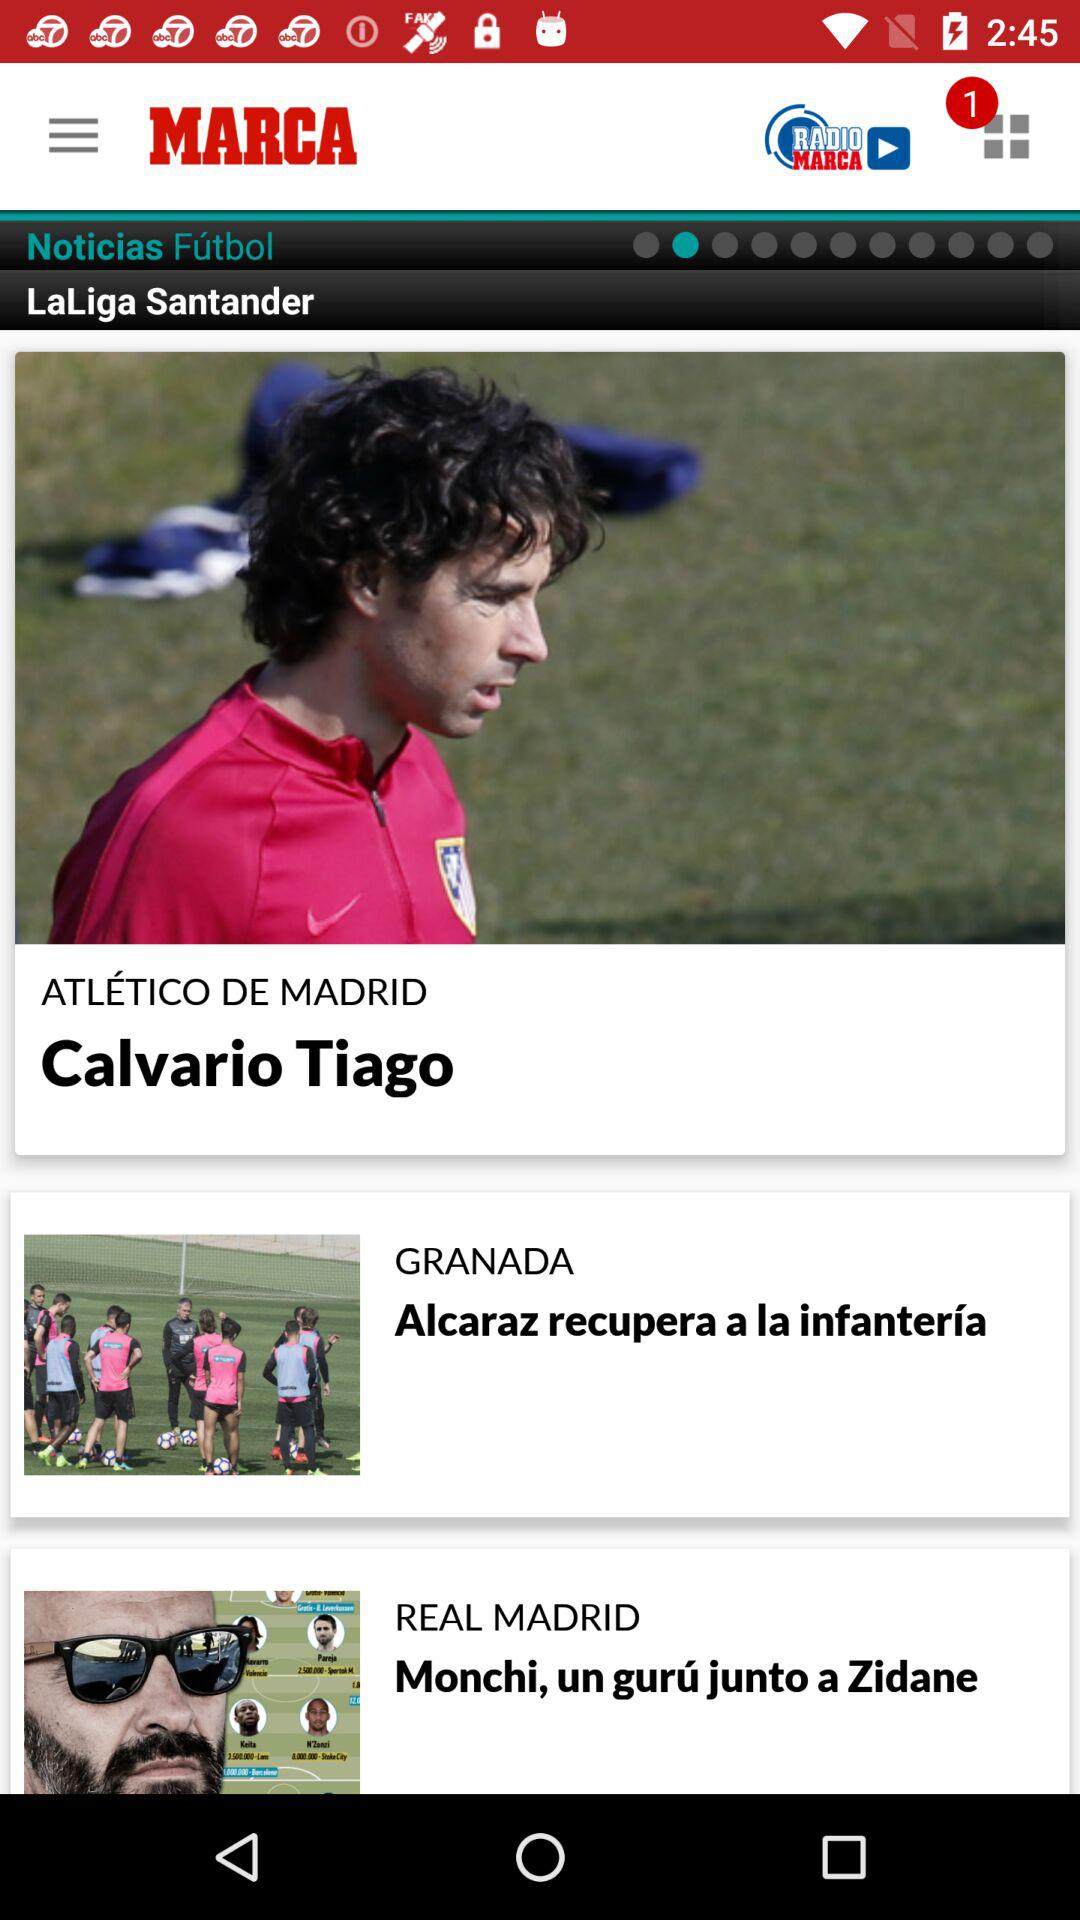How many articles are there in total?
Answer the question using a single word or phrase. 3 